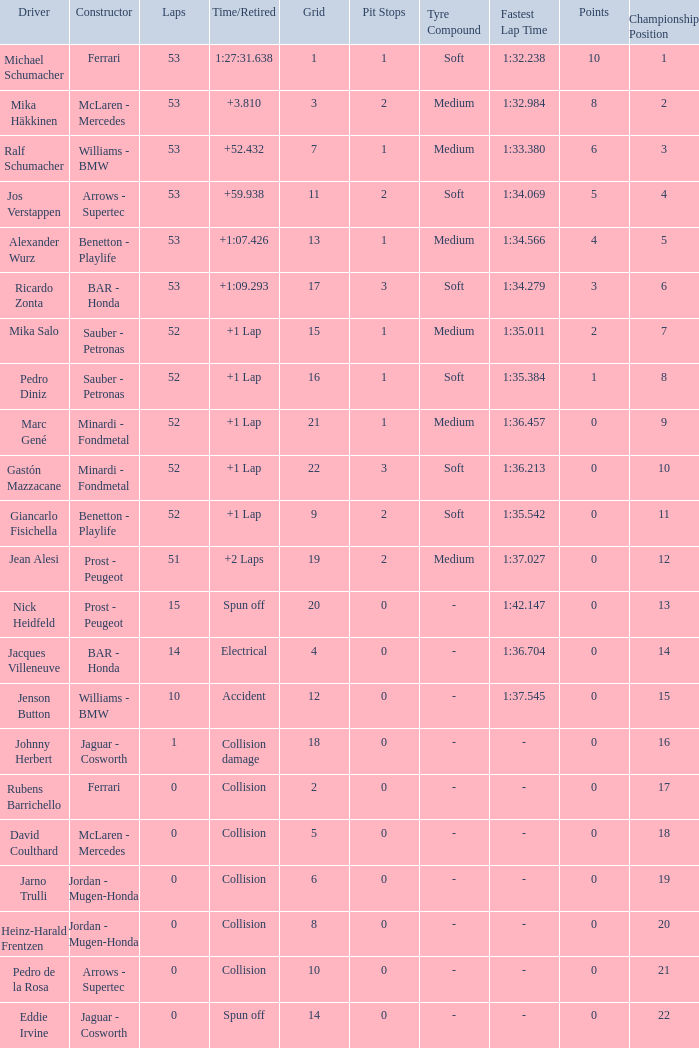What is the average Laps for a grid smaller than 17, and a Constructor of williams - bmw, driven by jenson button? 10.0. 